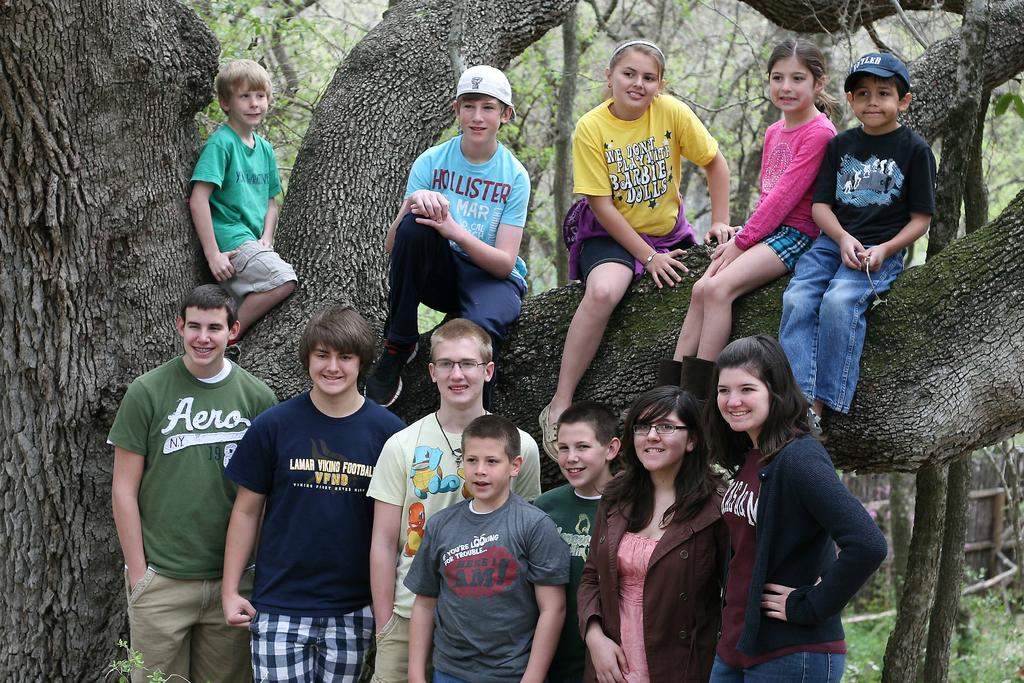What types of children are present in the image? There are boys and girls in the image. What are the children doing in the image? Some of the children are standing, while others are seated on a tree branch. What can be seen in the background of the image? There are trees visible in the background of the image. What type of clothing accessory can be seen on some of the children's heads? Some of the children are wearing caps on their heads. What type of force is being applied to the trucks in the image? There are no trucks present in the image; it features children standing and seated on a tree branch. 